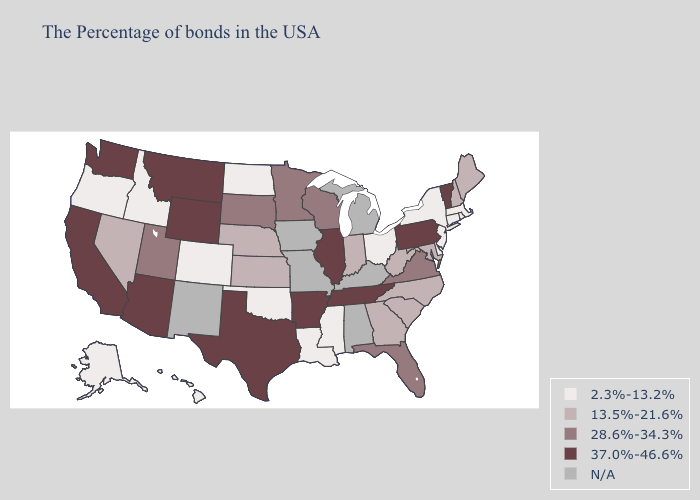Is the legend a continuous bar?
Quick response, please. No. Name the states that have a value in the range 28.6%-34.3%?
Short answer required. Virginia, Florida, Wisconsin, Minnesota, South Dakota, Utah. Does Idaho have the highest value in the USA?
Short answer required. No. What is the value of Kansas?
Quick response, please. 13.5%-21.6%. What is the value of Massachusetts?
Write a very short answer. 2.3%-13.2%. Name the states that have a value in the range 13.5%-21.6%?
Write a very short answer. Maine, New Hampshire, Maryland, North Carolina, South Carolina, West Virginia, Georgia, Indiana, Kansas, Nebraska, Nevada. Is the legend a continuous bar?
Give a very brief answer. No. What is the value of Ohio?
Quick response, please. 2.3%-13.2%. What is the value of North Dakota?
Quick response, please. 2.3%-13.2%. Which states hav the highest value in the West?
Give a very brief answer. Wyoming, Montana, Arizona, California, Washington. What is the lowest value in the West?
Give a very brief answer. 2.3%-13.2%. Does Minnesota have the lowest value in the MidWest?
Quick response, please. No. What is the value of Minnesota?
Quick response, please. 28.6%-34.3%. 